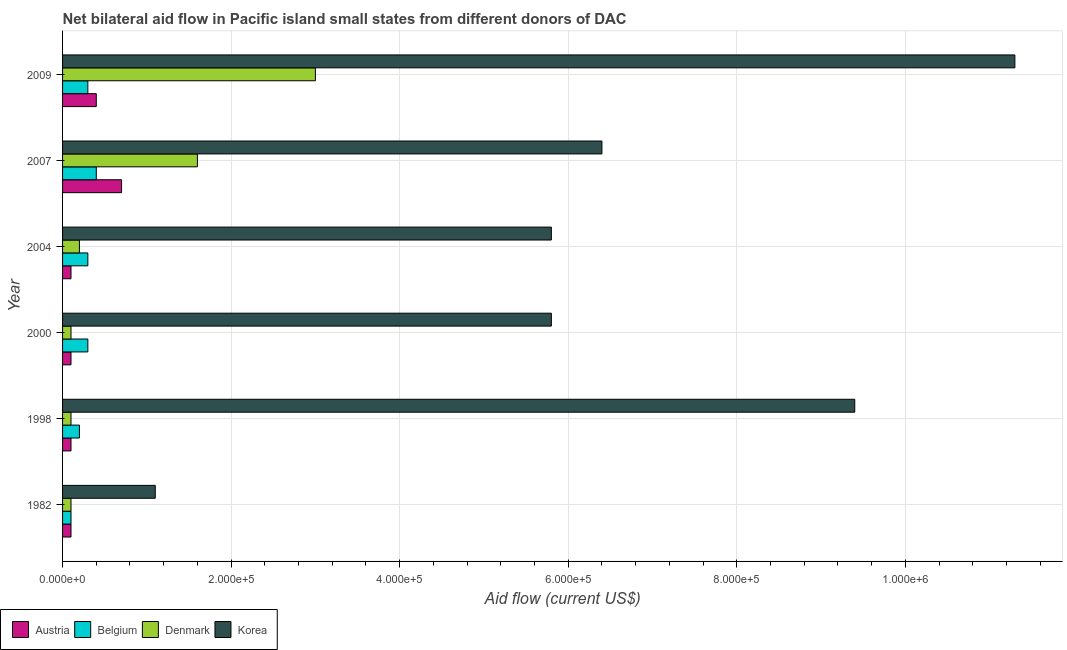Are the number of bars per tick equal to the number of legend labels?
Make the answer very short. Yes. Are the number of bars on each tick of the Y-axis equal?
Offer a terse response. Yes. How many bars are there on the 3rd tick from the top?
Keep it short and to the point. 4. What is the label of the 5th group of bars from the top?
Your answer should be compact. 1998. What is the amount of aid given by belgium in 2000?
Offer a very short reply. 3.00e+04. Across all years, what is the maximum amount of aid given by denmark?
Give a very brief answer. 3.00e+05. Across all years, what is the minimum amount of aid given by korea?
Provide a succinct answer. 1.10e+05. In which year was the amount of aid given by denmark maximum?
Your answer should be very brief. 2009. In which year was the amount of aid given by austria minimum?
Offer a terse response. 1982. What is the total amount of aid given by austria in the graph?
Your response must be concise. 1.50e+05. What is the difference between the amount of aid given by korea in 1982 and that in 2007?
Offer a very short reply. -5.30e+05. What is the difference between the amount of aid given by denmark in 2009 and the amount of aid given by korea in 1998?
Provide a succinct answer. -6.40e+05. What is the average amount of aid given by austria per year?
Your response must be concise. 2.50e+04. In the year 2009, what is the difference between the amount of aid given by korea and amount of aid given by austria?
Provide a succinct answer. 1.09e+06. In how many years, is the amount of aid given by belgium greater than 680000 US$?
Ensure brevity in your answer.  0. What is the ratio of the amount of aid given by korea in 1998 to that in 2004?
Provide a succinct answer. 1.62. Is the amount of aid given by denmark in 2000 less than that in 2009?
Offer a very short reply. Yes. What is the difference between the highest and the lowest amount of aid given by denmark?
Make the answer very short. 2.90e+05. In how many years, is the amount of aid given by austria greater than the average amount of aid given by austria taken over all years?
Your response must be concise. 2. Is the sum of the amount of aid given by denmark in 2007 and 2009 greater than the maximum amount of aid given by belgium across all years?
Offer a very short reply. Yes. What does the 1st bar from the top in 2007 represents?
Keep it short and to the point. Korea. What does the 4th bar from the bottom in 1998 represents?
Offer a terse response. Korea. Is it the case that in every year, the sum of the amount of aid given by austria and amount of aid given by belgium is greater than the amount of aid given by denmark?
Make the answer very short. No. Are all the bars in the graph horizontal?
Your answer should be very brief. Yes. What is the difference between two consecutive major ticks on the X-axis?
Offer a very short reply. 2.00e+05. Does the graph contain any zero values?
Your answer should be compact. No. Does the graph contain grids?
Provide a short and direct response. Yes. Where does the legend appear in the graph?
Ensure brevity in your answer.  Bottom left. How many legend labels are there?
Offer a very short reply. 4. How are the legend labels stacked?
Offer a very short reply. Horizontal. What is the title of the graph?
Your answer should be compact. Net bilateral aid flow in Pacific island small states from different donors of DAC. Does "Miscellaneous expenses" appear as one of the legend labels in the graph?
Your answer should be very brief. No. What is the label or title of the X-axis?
Your response must be concise. Aid flow (current US$). What is the label or title of the Y-axis?
Make the answer very short. Year. What is the Aid flow (current US$) of Austria in 1998?
Ensure brevity in your answer.  10000. What is the Aid flow (current US$) of Belgium in 1998?
Your response must be concise. 2.00e+04. What is the Aid flow (current US$) of Denmark in 1998?
Give a very brief answer. 10000. What is the Aid flow (current US$) in Korea in 1998?
Offer a terse response. 9.40e+05. What is the Aid flow (current US$) of Austria in 2000?
Ensure brevity in your answer.  10000. What is the Aid flow (current US$) of Korea in 2000?
Provide a succinct answer. 5.80e+05. What is the Aid flow (current US$) in Austria in 2004?
Your response must be concise. 10000. What is the Aid flow (current US$) in Korea in 2004?
Provide a short and direct response. 5.80e+05. What is the Aid flow (current US$) of Belgium in 2007?
Offer a terse response. 4.00e+04. What is the Aid flow (current US$) in Denmark in 2007?
Make the answer very short. 1.60e+05. What is the Aid flow (current US$) in Korea in 2007?
Give a very brief answer. 6.40e+05. What is the Aid flow (current US$) in Denmark in 2009?
Provide a succinct answer. 3.00e+05. What is the Aid flow (current US$) of Korea in 2009?
Your answer should be compact. 1.13e+06. Across all years, what is the maximum Aid flow (current US$) in Belgium?
Give a very brief answer. 4.00e+04. Across all years, what is the maximum Aid flow (current US$) in Denmark?
Offer a terse response. 3.00e+05. Across all years, what is the maximum Aid flow (current US$) of Korea?
Ensure brevity in your answer.  1.13e+06. Across all years, what is the minimum Aid flow (current US$) of Austria?
Keep it short and to the point. 10000. Across all years, what is the minimum Aid flow (current US$) of Belgium?
Your answer should be very brief. 10000. What is the total Aid flow (current US$) in Austria in the graph?
Your answer should be compact. 1.50e+05. What is the total Aid flow (current US$) of Denmark in the graph?
Keep it short and to the point. 5.10e+05. What is the total Aid flow (current US$) of Korea in the graph?
Keep it short and to the point. 3.98e+06. What is the difference between the Aid flow (current US$) of Austria in 1982 and that in 1998?
Offer a terse response. 0. What is the difference between the Aid flow (current US$) of Denmark in 1982 and that in 1998?
Provide a succinct answer. 0. What is the difference between the Aid flow (current US$) of Korea in 1982 and that in 1998?
Your answer should be compact. -8.30e+05. What is the difference between the Aid flow (current US$) in Austria in 1982 and that in 2000?
Your answer should be compact. 0. What is the difference between the Aid flow (current US$) in Belgium in 1982 and that in 2000?
Make the answer very short. -2.00e+04. What is the difference between the Aid flow (current US$) in Denmark in 1982 and that in 2000?
Provide a short and direct response. 0. What is the difference between the Aid flow (current US$) of Korea in 1982 and that in 2000?
Keep it short and to the point. -4.70e+05. What is the difference between the Aid flow (current US$) in Belgium in 1982 and that in 2004?
Provide a short and direct response. -2.00e+04. What is the difference between the Aid flow (current US$) of Denmark in 1982 and that in 2004?
Make the answer very short. -10000. What is the difference between the Aid flow (current US$) of Korea in 1982 and that in 2004?
Your answer should be compact. -4.70e+05. What is the difference between the Aid flow (current US$) of Austria in 1982 and that in 2007?
Offer a terse response. -6.00e+04. What is the difference between the Aid flow (current US$) in Denmark in 1982 and that in 2007?
Your response must be concise. -1.50e+05. What is the difference between the Aid flow (current US$) of Korea in 1982 and that in 2007?
Your answer should be compact. -5.30e+05. What is the difference between the Aid flow (current US$) in Austria in 1982 and that in 2009?
Ensure brevity in your answer.  -3.00e+04. What is the difference between the Aid flow (current US$) in Denmark in 1982 and that in 2009?
Make the answer very short. -2.90e+05. What is the difference between the Aid flow (current US$) in Korea in 1982 and that in 2009?
Provide a succinct answer. -1.02e+06. What is the difference between the Aid flow (current US$) of Austria in 1998 and that in 2000?
Provide a short and direct response. 0. What is the difference between the Aid flow (current US$) in Belgium in 1998 and that in 2000?
Your answer should be very brief. -10000. What is the difference between the Aid flow (current US$) in Belgium in 1998 and that in 2004?
Provide a succinct answer. -10000. What is the difference between the Aid flow (current US$) in Korea in 1998 and that in 2004?
Ensure brevity in your answer.  3.60e+05. What is the difference between the Aid flow (current US$) of Austria in 1998 and that in 2007?
Your response must be concise. -6.00e+04. What is the difference between the Aid flow (current US$) of Belgium in 1998 and that in 2007?
Offer a very short reply. -2.00e+04. What is the difference between the Aid flow (current US$) of Denmark in 1998 and that in 2007?
Make the answer very short. -1.50e+05. What is the difference between the Aid flow (current US$) of Korea in 1998 and that in 2007?
Ensure brevity in your answer.  3.00e+05. What is the difference between the Aid flow (current US$) in Austria in 1998 and that in 2009?
Keep it short and to the point. -3.00e+04. What is the difference between the Aid flow (current US$) in Korea in 1998 and that in 2009?
Your response must be concise. -1.90e+05. What is the difference between the Aid flow (current US$) of Austria in 2000 and that in 2004?
Offer a terse response. 0. What is the difference between the Aid flow (current US$) of Korea in 2000 and that in 2004?
Give a very brief answer. 0. What is the difference between the Aid flow (current US$) in Austria in 2000 and that in 2007?
Ensure brevity in your answer.  -6.00e+04. What is the difference between the Aid flow (current US$) in Denmark in 2000 and that in 2007?
Give a very brief answer. -1.50e+05. What is the difference between the Aid flow (current US$) in Korea in 2000 and that in 2007?
Offer a terse response. -6.00e+04. What is the difference between the Aid flow (current US$) in Austria in 2000 and that in 2009?
Provide a short and direct response. -3.00e+04. What is the difference between the Aid flow (current US$) in Belgium in 2000 and that in 2009?
Ensure brevity in your answer.  0. What is the difference between the Aid flow (current US$) of Denmark in 2000 and that in 2009?
Make the answer very short. -2.90e+05. What is the difference between the Aid flow (current US$) of Korea in 2000 and that in 2009?
Offer a terse response. -5.50e+05. What is the difference between the Aid flow (current US$) of Belgium in 2004 and that in 2007?
Keep it short and to the point. -10000. What is the difference between the Aid flow (current US$) in Korea in 2004 and that in 2007?
Offer a terse response. -6.00e+04. What is the difference between the Aid flow (current US$) of Belgium in 2004 and that in 2009?
Your answer should be very brief. 0. What is the difference between the Aid flow (current US$) in Denmark in 2004 and that in 2009?
Offer a very short reply. -2.80e+05. What is the difference between the Aid flow (current US$) in Korea in 2004 and that in 2009?
Your response must be concise. -5.50e+05. What is the difference between the Aid flow (current US$) in Austria in 2007 and that in 2009?
Offer a very short reply. 3.00e+04. What is the difference between the Aid flow (current US$) in Denmark in 2007 and that in 2009?
Offer a very short reply. -1.40e+05. What is the difference between the Aid flow (current US$) of Korea in 2007 and that in 2009?
Ensure brevity in your answer.  -4.90e+05. What is the difference between the Aid flow (current US$) of Austria in 1982 and the Aid flow (current US$) of Korea in 1998?
Give a very brief answer. -9.30e+05. What is the difference between the Aid flow (current US$) of Belgium in 1982 and the Aid flow (current US$) of Denmark in 1998?
Make the answer very short. 0. What is the difference between the Aid flow (current US$) in Belgium in 1982 and the Aid flow (current US$) in Korea in 1998?
Provide a short and direct response. -9.30e+05. What is the difference between the Aid flow (current US$) in Denmark in 1982 and the Aid flow (current US$) in Korea in 1998?
Give a very brief answer. -9.30e+05. What is the difference between the Aid flow (current US$) in Austria in 1982 and the Aid flow (current US$) in Belgium in 2000?
Your answer should be very brief. -2.00e+04. What is the difference between the Aid flow (current US$) in Austria in 1982 and the Aid flow (current US$) in Denmark in 2000?
Your answer should be very brief. 0. What is the difference between the Aid flow (current US$) of Austria in 1982 and the Aid flow (current US$) of Korea in 2000?
Provide a short and direct response. -5.70e+05. What is the difference between the Aid flow (current US$) of Belgium in 1982 and the Aid flow (current US$) of Denmark in 2000?
Make the answer very short. 0. What is the difference between the Aid flow (current US$) in Belgium in 1982 and the Aid flow (current US$) in Korea in 2000?
Keep it short and to the point. -5.70e+05. What is the difference between the Aid flow (current US$) in Denmark in 1982 and the Aid flow (current US$) in Korea in 2000?
Provide a short and direct response. -5.70e+05. What is the difference between the Aid flow (current US$) of Austria in 1982 and the Aid flow (current US$) of Denmark in 2004?
Your response must be concise. -10000. What is the difference between the Aid flow (current US$) of Austria in 1982 and the Aid flow (current US$) of Korea in 2004?
Provide a short and direct response. -5.70e+05. What is the difference between the Aid flow (current US$) in Belgium in 1982 and the Aid flow (current US$) in Korea in 2004?
Your answer should be very brief. -5.70e+05. What is the difference between the Aid flow (current US$) in Denmark in 1982 and the Aid flow (current US$) in Korea in 2004?
Your answer should be very brief. -5.70e+05. What is the difference between the Aid flow (current US$) in Austria in 1982 and the Aid flow (current US$) in Belgium in 2007?
Give a very brief answer. -3.00e+04. What is the difference between the Aid flow (current US$) of Austria in 1982 and the Aid flow (current US$) of Denmark in 2007?
Offer a terse response. -1.50e+05. What is the difference between the Aid flow (current US$) of Austria in 1982 and the Aid flow (current US$) of Korea in 2007?
Provide a short and direct response. -6.30e+05. What is the difference between the Aid flow (current US$) of Belgium in 1982 and the Aid flow (current US$) of Denmark in 2007?
Make the answer very short. -1.50e+05. What is the difference between the Aid flow (current US$) in Belgium in 1982 and the Aid flow (current US$) in Korea in 2007?
Your answer should be compact. -6.30e+05. What is the difference between the Aid flow (current US$) in Denmark in 1982 and the Aid flow (current US$) in Korea in 2007?
Make the answer very short. -6.30e+05. What is the difference between the Aid flow (current US$) of Austria in 1982 and the Aid flow (current US$) of Belgium in 2009?
Offer a terse response. -2.00e+04. What is the difference between the Aid flow (current US$) in Austria in 1982 and the Aid flow (current US$) in Korea in 2009?
Offer a terse response. -1.12e+06. What is the difference between the Aid flow (current US$) of Belgium in 1982 and the Aid flow (current US$) of Denmark in 2009?
Your answer should be very brief. -2.90e+05. What is the difference between the Aid flow (current US$) of Belgium in 1982 and the Aid flow (current US$) of Korea in 2009?
Your answer should be compact. -1.12e+06. What is the difference between the Aid flow (current US$) in Denmark in 1982 and the Aid flow (current US$) in Korea in 2009?
Offer a very short reply. -1.12e+06. What is the difference between the Aid flow (current US$) of Austria in 1998 and the Aid flow (current US$) of Belgium in 2000?
Provide a short and direct response. -2.00e+04. What is the difference between the Aid flow (current US$) in Austria in 1998 and the Aid flow (current US$) in Denmark in 2000?
Provide a succinct answer. 0. What is the difference between the Aid flow (current US$) of Austria in 1998 and the Aid flow (current US$) of Korea in 2000?
Provide a succinct answer. -5.70e+05. What is the difference between the Aid flow (current US$) of Belgium in 1998 and the Aid flow (current US$) of Denmark in 2000?
Offer a very short reply. 10000. What is the difference between the Aid flow (current US$) of Belgium in 1998 and the Aid flow (current US$) of Korea in 2000?
Your response must be concise. -5.60e+05. What is the difference between the Aid flow (current US$) of Denmark in 1998 and the Aid flow (current US$) of Korea in 2000?
Provide a succinct answer. -5.70e+05. What is the difference between the Aid flow (current US$) in Austria in 1998 and the Aid flow (current US$) in Denmark in 2004?
Provide a short and direct response. -10000. What is the difference between the Aid flow (current US$) of Austria in 1998 and the Aid flow (current US$) of Korea in 2004?
Your response must be concise. -5.70e+05. What is the difference between the Aid flow (current US$) in Belgium in 1998 and the Aid flow (current US$) in Korea in 2004?
Provide a short and direct response. -5.60e+05. What is the difference between the Aid flow (current US$) in Denmark in 1998 and the Aid flow (current US$) in Korea in 2004?
Offer a very short reply. -5.70e+05. What is the difference between the Aid flow (current US$) of Austria in 1998 and the Aid flow (current US$) of Belgium in 2007?
Give a very brief answer. -3.00e+04. What is the difference between the Aid flow (current US$) of Austria in 1998 and the Aid flow (current US$) of Denmark in 2007?
Give a very brief answer. -1.50e+05. What is the difference between the Aid flow (current US$) in Austria in 1998 and the Aid flow (current US$) in Korea in 2007?
Provide a succinct answer. -6.30e+05. What is the difference between the Aid flow (current US$) of Belgium in 1998 and the Aid flow (current US$) of Denmark in 2007?
Keep it short and to the point. -1.40e+05. What is the difference between the Aid flow (current US$) in Belgium in 1998 and the Aid flow (current US$) in Korea in 2007?
Provide a succinct answer. -6.20e+05. What is the difference between the Aid flow (current US$) in Denmark in 1998 and the Aid flow (current US$) in Korea in 2007?
Provide a succinct answer. -6.30e+05. What is the difference between the Aid flow (current US$) of Austria in 1998 and the Aid flow (current US$) of Korea in 2009?
Offer a terse response. -1.12e+06. What is the difference between the Aid flow (current US$) of Belgium in 1998 and the Aid flow (current US$) of Denmark in 2009?
Provide a succinct answer. -2.80e+05. What is the difference between the Aid flow (current US$) of Belgium in 1998 and the Aid flow (current US$) of Korea in 2009?
Keep it short and to the point. -1.11e+06. What is the difference between the Aid flow (current US$) in Denmark in 1998 and the Aid flow (current US$) in Korea in 2009?
Your answer should be compact. -1.12e+06. What is the difference between the Aid flow (current US$) in Austria in 2000 and the Aid flow (current US$) in Belgium in 2004?
Your answer should be compact. -2.00e+04. What is the difference between the Aid flow (current US$) in Austria in 2000 and the Aid flow (current US$) in Korea in 2004?
Offer a terse response. -5.70e+05. What is the difference between the Aid flow (current US$) of Belgium in 2000 and the Aid flow (current US$) of Denmark in 2004?
Offer a very short reply. 10000. What is the difference between the Aid flow (current US$) of Belgium in 2000 and the Aid flow (current US$) of Korea in 2004?
Your answer should be compact. -5.50e+05. What is the difference between the Aid flow (current US$) of Denmark in 2000 and the Aid flow (current US$) of Korea in 2004?
Give a very brief answer. -5.70e+05. What is the difference between the Aid flow (current US$) of Austria in 2000 and the Aid flow (current US$) of Belgium in 2007?
Offer a very short reply. -3.00e+04. What is the difference between the Aid flow (current US$) of Austria in 2000 and the Aid flow (current US$) of Denmark in 2007?
Ensure brevity in your answer.  -1.50e+05. What is the difference between the Aid flow (current US$) of Austria in 2000 and the Aid flow (current US$) of Korea in 2007?
Your response must be concise. -6.30e+05. What is the difference between the Aid flow (current US$) in Belgium in 2000 and the Aid flow (current US$) in Korea in 2007?
Provide a short and direct response. -6.10e+05. What is the difference between the Aid flow (current US$) in Denmark in 2000 and the Aid flow (current US$) in Korea in 2007?
Offer a terse response. -6.30e+05. What is the difference between the Aid flow (current US$) of Austria in 2000 and the Aid flow (current US$) of Belgium in 2009?
Give a very brief answer. -2.00e+04. What is the difference between the Aid flow (current US$) in Austria in 2000 and the Aid flow (current US$) in Denmark in 2009?
Provide a short and direct response. -2.90e+05. What is the difference between the Aid flow (current US$) of Austria in 2000 and the Aid flow (current US$) of Korea in 2009?
Your answer should be very brief. -1.12e+06. What is the difference between the Aid flow (current US$) in Belgium in 2000 and the Aid flow (current US$) in Denmark in 2009?
Offer a terse response. -2.70e+05. What is the difference between the Aid flow (current US$) of Belgium in 2000 and the Aid flow (current US$) of Korea in 2009?
Your answer should be compact. -1.10e+06. What is the difference between the Aid flow (current US$) of Denmark in 2000 and the Aid flow (current US$) of Korea in 2009?
Ensure brevity in your answer.  -1.12e+06. What is the difference between the Aid flow (current US$) in Austria in 2004 and the Aid flow (current US$) in Korea in 2007?
Provide a short and direct response. -6.30e+05. What is the difference between the Aid flow (current US$) in Belgium in 2004 and the Aid flow (current US$) in Denmark in 2007?
Ensure brevity in your answer.  -1.30e+05. What is the difference between the Aid flow (current US$) of Belgium in 2004 and the Aid flow (current US$) of Korea in 2007?
Ensure brevity in your answer.  -6.10e+05. What is the difference between the Aid flow (current US$) of Denmark in 2004 and the Aid flow (current US$) of Korea in 2007?
Make the answer very short. -6.20e+05. What is the difference between the Aid flow (current US$) in Austria in 2004 and the Aid flow (current US$) in Belgium in 2009?
Offer a terse response. -2.00e+04. What is the difference between the Aid flow (current US$) of Austria in 2004 and the Aid flow (current US$) of Denmark in 2009?
Ensure brevity in your answer.  -2.90e+05. What is the difference between the Aid flow (current US$) of Austria in 2004 and the Aid flow (current US$) of Korea in 2009?
Your answer should be compact. -1.12e+06. What is the difference between the Aid flow (current US$) in Belgium in 2004 and the Aid flow (current US$) in Denmark in 2009?
Your answer should be compact. -2.70e+05. What is the difference between the Aid flow (current US$) of Belgium in 2004 and the Aid flow (current US$) of Korea in 2009?
Offer a terse response. -1.10e+06. What is the difference between the Aid flow (current US$) in Denmark in 2004 and the Aid flow (current US$) in Korea in 2009?
Ensure brevity in your answer.  -1.11e+06. What is the difference between the Aid flow (current US$) in Austria in 2007 and the Aid flow (current US$) in Korea in 2009?
Your answer should be very brief. -1.06e+06. What is the difference between the Aid flow (current US$) in Belgium in 2007 and the Aid flow (current US$) in Denmark in 2009?
Ensure brevity in your answer.  -2.60e+05. What is the difference between the Aid flow (current US$) in Belgium in 2007 and the Aid flow (current US$) in Korea in 2009?
Keep it short and to the point. -1.09e+06. What is the difference between the Aid flow (current US$) in Denmark in 2007 and the Aid flow (current US$) in Korea in 2009?
Offer a very short reply. -9.70e+05. What is the average Aid flow (current US$) of Austria per year?
Offer a very short reply. 2.50e+04. What is the average Aid flow (current US$) of Belgium per year?
Your answer should be very brief. 2.67e+04. What is the average Aid flow (current US$) in Denmark per year?
Your answer should be very brief. 8.50e+04. What is the average Aid flow (current US$) of Korea per year?
Your answer should be very brief. 6.63e+05. In the year 1982, what is the difference between the Aid flow (current US$) in Austria and Aid flow (current US$) in Belgium?
Provide a short and direct response. 0. In the year 1982, what is the difference between the Aid flow (current US$) in Austria and Aid flow (current US$) in Denmark?
Give a very brief answer. 0. In the year 1998, what is the difference between the Aid flow (current US$) of Austria and Aid flow (current US$) of Korea?
Keep it short and to the point. -9.30e+05. In the year 1998, what is the difference between the Aid flow (current US$) in Belgium and Aid flow (current US$) in Denmark?
Your answer should be very brief. 10000. In the year 1998, what is the difference between the Aid flow (current US$) in Belgium and Aid flow (current US$) in Korea?
Provide a succinct answer. -9.20e+05. In the year 1998, what is the difference between the Aid flow (current US$) in Denmark and Aid flow (current US$) in Korea?
Keep it short and to the point. -9.30e+05. In the year 2000, what is the difference between the Aid flow (current US$) in Austria and Aid flow (current US$) in Denmark?
Your response must be concise. 0. In the year 2000, what is the difference between the Aid flow (current US$) of Austria and Aid flow (current US$) of Korea?
Offer a terse response. -5.70e+05. In the year 2000, what is the difference between the Aid flow (current US$) of Belgium and Aid flow (current US$) of Korea?
Offer a terse response. -5.50e+05. In the year 2000, what is the difference between the Aid flow (current US$) of Denmark and Aid flow (current US$) of Korea?
Offer a very short reply. -5.70e+05. In the year 2004, what is the difference between the Aid flow (current US$) of Austria and Aid flow (current US$) of Belgium?
Offer a terse response. -2.00e+04. In the year 2004, what is the difference between the Aid flow (current US$) in Austria and Aid flow (current US$) in Korea?
Keep it short and to the point. -5.70e+05. In the year 2004, what is the difference between the Aid flow (current US$) of Belgium and Aid flow (current US$) of Denmark?
Your answer should be compact. 10000. In the year 2004, what is the difference between the Aid flow (current US$) in Belgium and Aid flow (current US$) in Korea?
Provide a short and direct response. -5.50e+05. In the year 2004, what is the difference between the Aid flow (current US$) of Denmark and Aid flow (current US$) of Korea?
Your answer should be compact. -5.60e+05. In the year 2007, what is the difference between the Aid flow (current US$) of Austria and Aid flow (current US$) of Denmark?
Your response must be concise. -9.00e+04. In the year 2007, what is the difference between the Aid flow (current US$) of Austria and Aid flow (current US$) of Korea?
Provide a short and direct response. -5.70e+05. In the year 2007, what is the difference between the Aid flow (current US$) of Belgium and Aid flow (current US$) of Korea?
Your response must be concise. -6.00e+05. In the year 2007, what is the difference between the Aid flow (current US$) in Denmark and Aid flow (current US$) in Korea?
Your answer should be compact. -4.80e+05. In the year 2009, what is the difference between the Aid flow (current US$) of Austria and Aid flow (current US$) of Belgium?
Provide a short and direct response. 10000. In the year 2009, what is the difference between the Aid flow (current US$) in Austria and Aid flow (current US$) in Denmark?
Give a very brief answer. -2.60e+05. In the year 2009, what is the difference between the Aid flow (current US$) of Austria and Aid flow (current US$) of Korea?
Provide a succinct answer. -1.09e+06. In the year 2009, what is the difference between the Aid flow (current US$) in Belgium and Aid flow (current US$) in Korea?
Give a very brief answer. -1.10e+06. In the year 2009, what is the difference between the Aid flow (current US$) of Denmark and Aid flow (current US$) of Korea?
Provide a short and direct response. -8.30e+05. What is the ratio of the Aid flow (current US$) in Austria in 1982 to that in 1998?
Provide a succinct answer. 1. What is the ratio of the Aid flow (current US$) in Korea in 1982 to that in 1998?
Give a very brief answer. 0.12. What is the ratio of the Aid flow (current US$) of Belgium in 1982 to that in 2000?
Give a very brief answer. 0.33. What is the ratio of the Aid flow (current US$) of Korea in 1982 to that in 2000?
Make the answer very short. 0.19. What is the ratio of the Aid flow (current US$) in Austria in 1982 to that in 2004?
Provide a succinct answer. 1. What is the ratio of the Aid flow (current US$) of Belgium in 1982 to that in 2004?
Keep it short and to the point. 0.33. What is the ratio of the Aid flow (current US$) in Korea in 1982 to that in 2004?
Give a very brief answer. 0.19. What is the ratio of the Aid flow (current US$) of Austria in 1982 to that in 2007?
Ensure brevity in your answer.  0.14. What is the ratio of the Aid flow (current US$) in Belgium in 1982 to that in 2007?
Keep it short and to the point. 0.25. What is the ratio of the Aid flow (current US$) of Denmark in 1982 to that in 2007?
Your response must be concise. 0.06. What is the ratio of the Aid flow (current US$) of Korea in 1982 to that in 2007?
Ensure brevity in your answer.  0.17. What is the ratio of the Aid flow (current US$) in Korea in 1982 to that in 2009?
Offer a very short reply. 0.1. What is the ratio of the Aid flow (current US$) in Austria in 1998 to that in 2000?
Ensure brevity in your answer.  1. What is the ratio of the Aid flow (current US$) of Korea in 1998 to that in 2000?
Give a very brief answer. 1.62. What is the ratio of the Aid flow (current US$) in Austria in 1998 to that in 2004?
Keep it short and to the point. 1. What is the ratio of the Aid flow (current US$) in Denmark in 1998 to that in 2004?
Offer a very short reply. 0.5. What is the ratio of the Aid flow (current US$) of Korea in 1998 to that in 2004?
Give a very brief answer. 1.62. What is the ratio of the Aid flow (current US$) of Austria in 1998 to that in 2007?
Ensure brevity in your answer.  0.14. What is the ratio of the Aid flow (current US$) of Belgium in 1998 to that in 2007?
Ensure brevity in your answer.  0.5. What is the ratio of the Aid flow (current US$) in Denmark in 1998 to that in 2007?
Make the answer very short. 0.06. What is the ratio of the Aid flow (current US$) of Korea in 1998 to that in 2007?
Offer a very short reply. 1.47. What is the ratio of the Aid flow (current US$) in Austria in 1998 to that in 2009?
Ensure brevity in your answer.  0.25. What is the ratio of the Aid flow (current US$) of Korea in 1998 to that in 2009?
Your answer should be compact. 0.83. What is the ratio of the Aid flow (current US$) of Belgium in 2000 to that in 2004?
Your response must be concise. 1. What is the ratio of the Aid flow (current US$) in Austria in 2000 to that in 2007?
Your answer should be compact. 0.14. What is the ratio of the Aid flow (current US$) of Denmark in 2000 to that in 2007?
Keep it short and to the point. 0.06. What is the ratio of the Aid flow (current US$) in Korea in 2000 to that in 2007?
Provide a short and direct response. 0.91. What is the ratio of the Aid flow (current US$) of Austria in 2000 to that in 2009?
Your response must be concise. 0.25. What is the ratio of the Aid flow (current US$) in Belgium in 2000 to that in 2009?
Provide a short and direct response. 1. What is the ratio of the Aid flow (current US$) in Denmark in 2000 to that in 2009?
Offer a very short reply. 0.03. What is the ratio of the Aid flow (current US$) of Korea in 2000 to that in 2009?
Your answer should be very brief. 0.51. What is the ratio of the Aid flow (current US$) of Austria in 2004 to that in 2007?
Your answer should be compact. 0.14. What is the ratio of the Aid flow (current US$) in Belgium in 2004 to that in 2007?
Provide a succinct answer. 0.75. What is the ratio of the Aid flow (current US$) of Korea in 2004 to that in 2007?
Ensure brevity in your answer.  0.91. What is the ratio of the Aid flow (current US$) of Denmark in 2004 to that in 2009?
Provide a succinct answer. 0.07. What is the ratio of the Aid flow (current US$) of Korea in 2004 to that in 2009?
Offer a terse response. 0.51. What is the ratio of the Aid flow (current US$) in Austria in 2007 to that in 2009?
Offer a terse response. 1.75. What is the ratio of the Aid flow (current US$) of Denmark in 2007 to that in 2009?
Provide a short and direct response. 0.53. What is the ratio of the Aid flow (current US$) in Korea in 2007 to that in 2009?
Give a very brief answer. 0.57. What is the difference between the highest and the second highest Aid flow (current US$) in Austria?
Your answer should be very brief. 3.00e+04. What is the difference between the highest and the lowest Aid flow (current US$) in Korea?
Keep it short and to the point. 1.02e+06. 